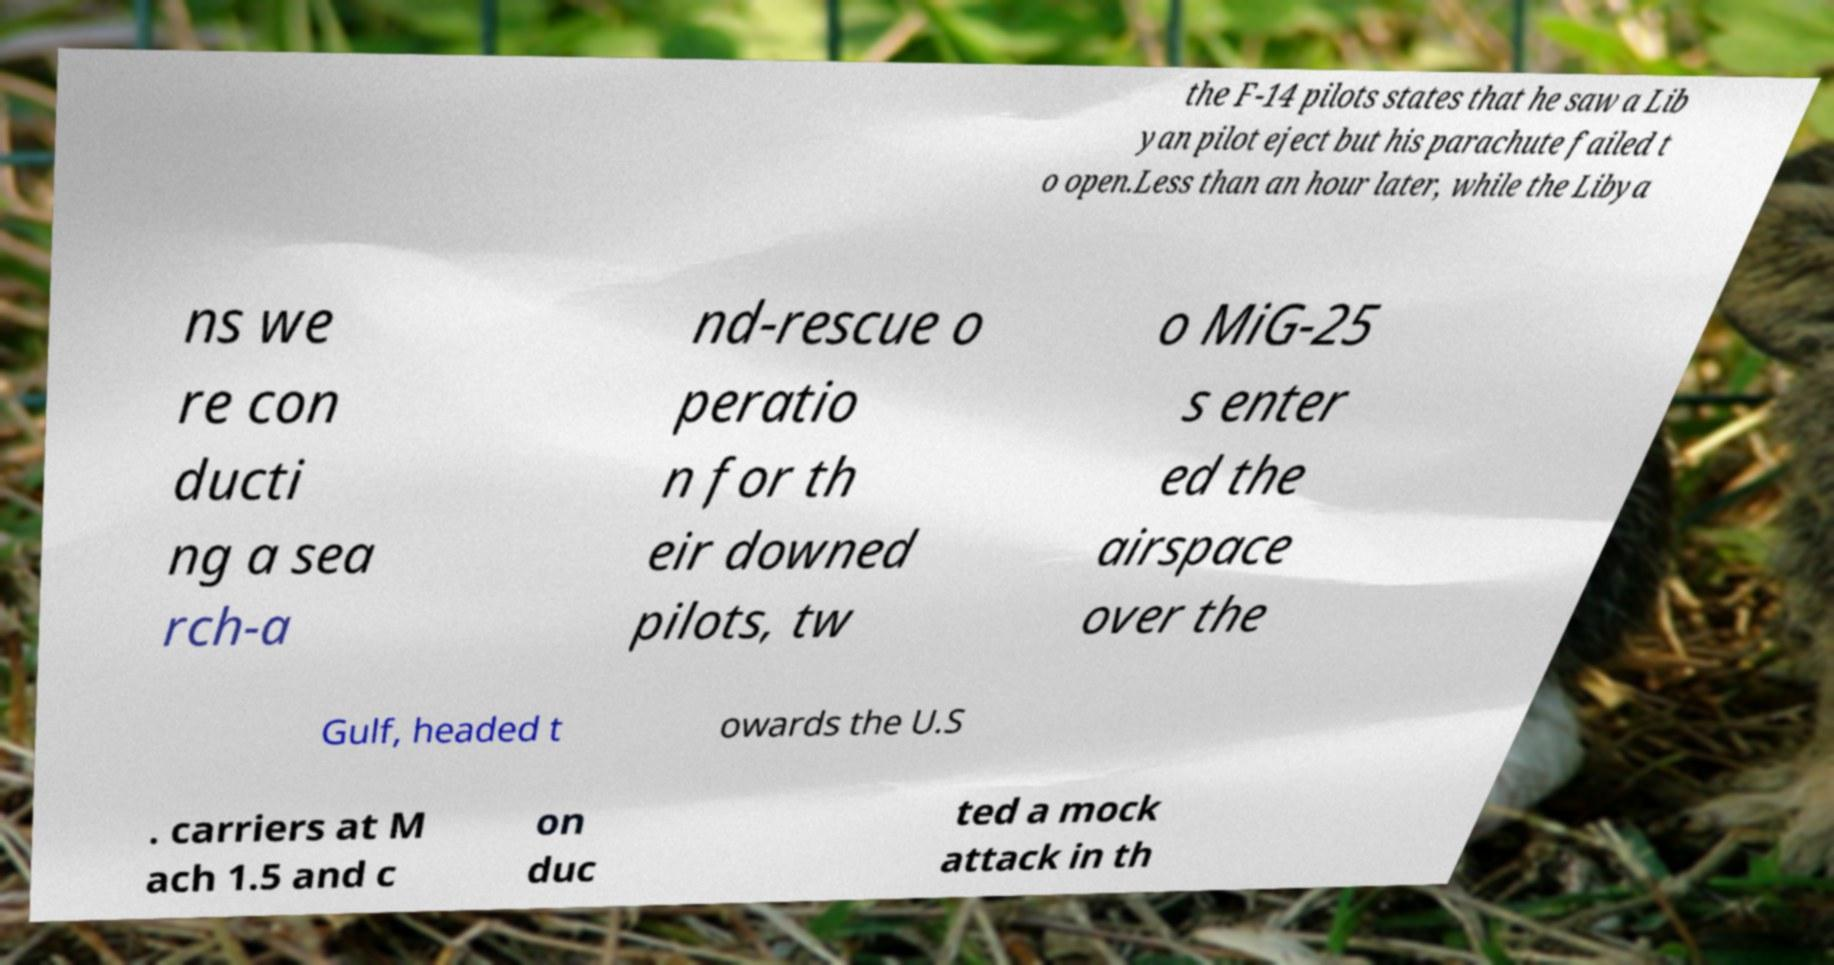What messages or text are displayed in this image? I need them in a readable, typed format. the F-14 pilots states that he saw a Lib yan pilot eject but his parachute failed t o open.Less than an hour later, while the Libya ns we re con ducti ng a sea rch-a nd-rescue o peratio n for th eir downed pilots, tw o MiG-25 s enter ed the airspace over the Gulf, headed t owards the U.S . carriers at M ach 1.5 and c on duc ted a mock attack in th 